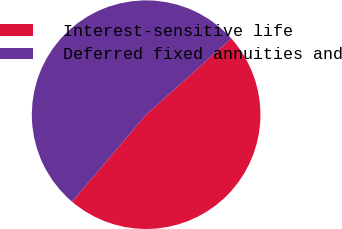<chart> <loc_0><loc_0><loc_500><loc_500><pie_chart><fcel>Interest-sensitive life<fcel>Deferred fixed annuities and<nl><fcel>47.83%<fcel>52.17%<nl></chart> 